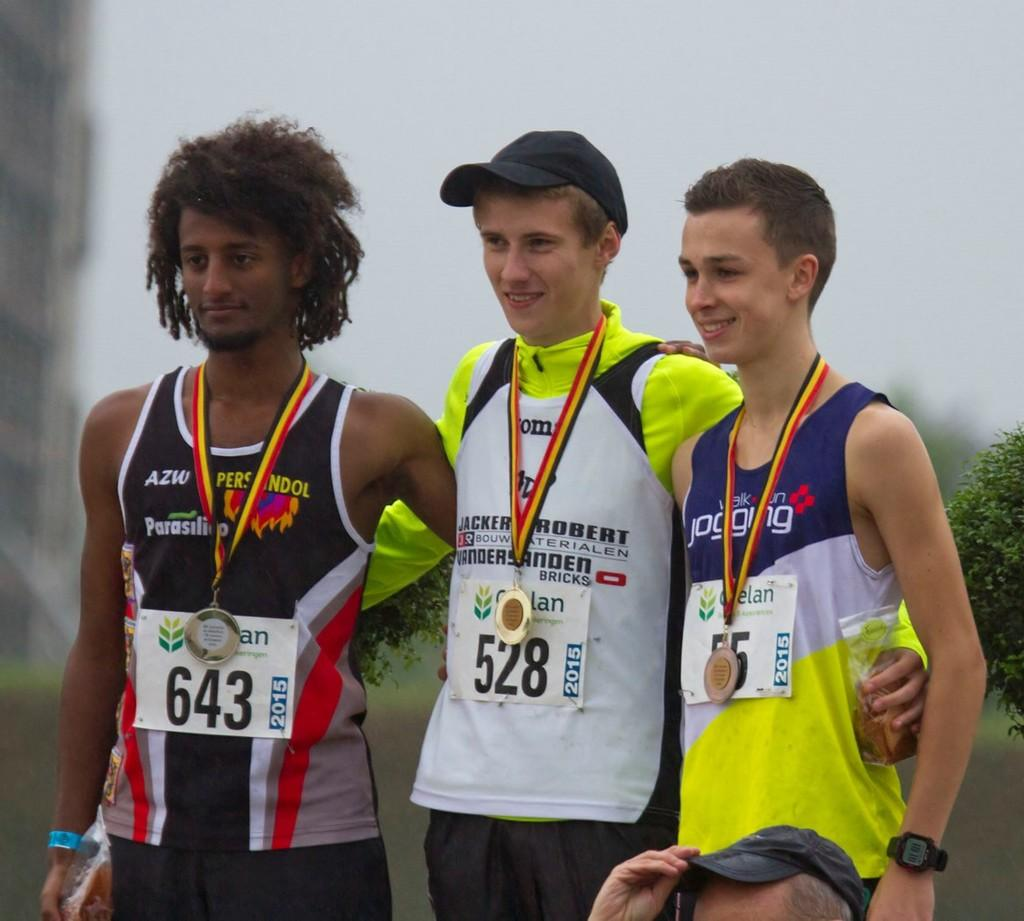<image>
Give a short and clear explanation of the subsequent image. Athletes pose wearing tag numbers 643, 528 and 55. 